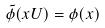Convert formula to latex. <formula><loc_0><loc_0><loc_500><loc_500>\tilde { \phi } ( x U ) = \phi ( x )</formula> 